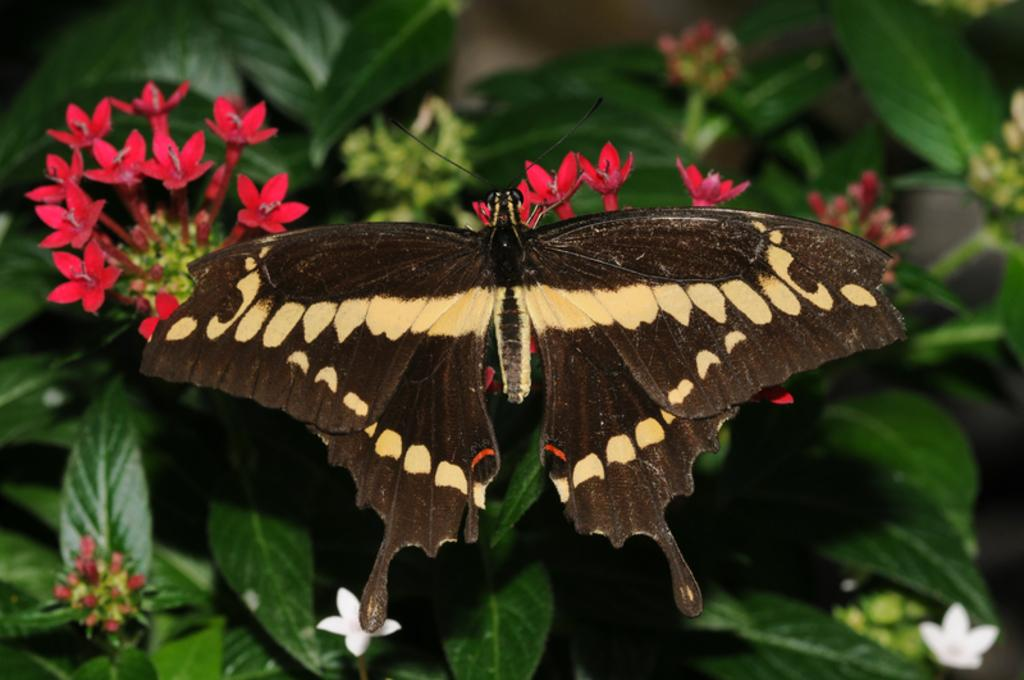What is the main subject of the image? The main subject of the image is a butterfly. Where is the butterfly located in the image? The butterfly is represented on flowers. What is the context of the butterfly and flowers in the image? The flowers are present on a plant. How does the butterfly use its mind to communicate with the pear in the image? There is no pear present in the image, and butterflies do not have minds or communicate with pears. 